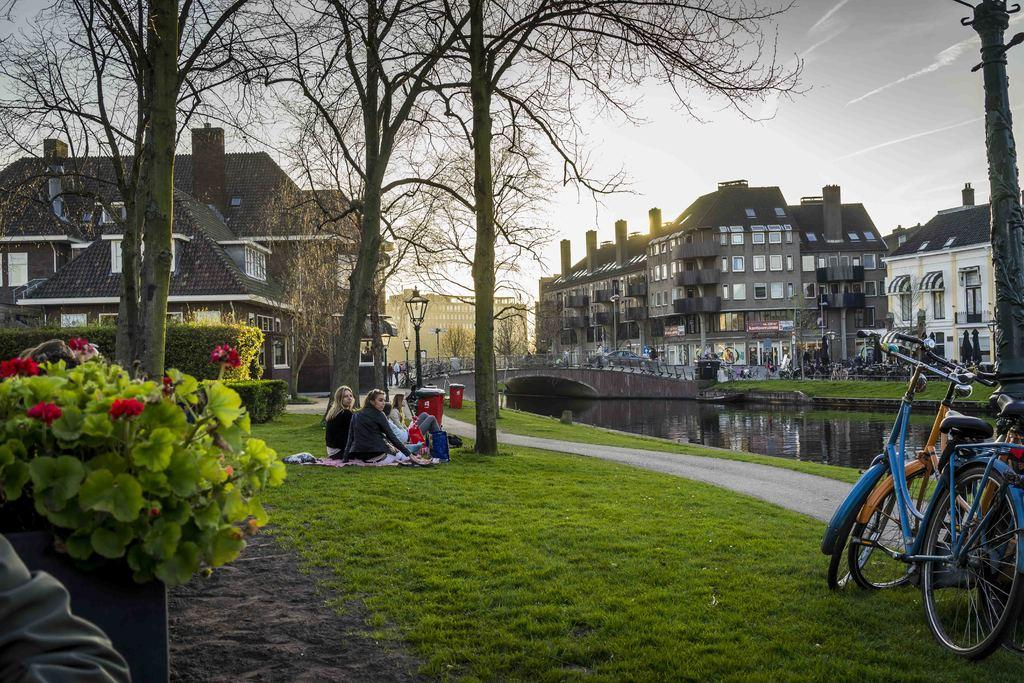How many people are sitting on the grass in the image? There are three persons sitting on the grass in the image. What type of vegetation can be seen in the image? There are plants and trees visible in the image. What can be seen in the water in the image? There is a bridge visible in the water in the image. What type of structures are present in the image? There are buildings visible in the image. Can you describe the group of people in the image? There is a group of people in the image, but the conversation has already mentioned that there are three persons sitting on the grass. What might be used for illumination in the image? There are lights visible in the image. What objects might be used for transportation in the image? There are bicycles visible in the image. What is visible in the sky in the image? The sky is visible in the image. What is the thought process of the chin in the image? There is no chin present in the image, as it is a photograph of a scene and not a portrait. What type of trade is being conducted in the image? There is no trade being conducted in the image; it depicts a scene with people, plants, trees, water, a bridge, buildings, lights, poles, and bicycles. 